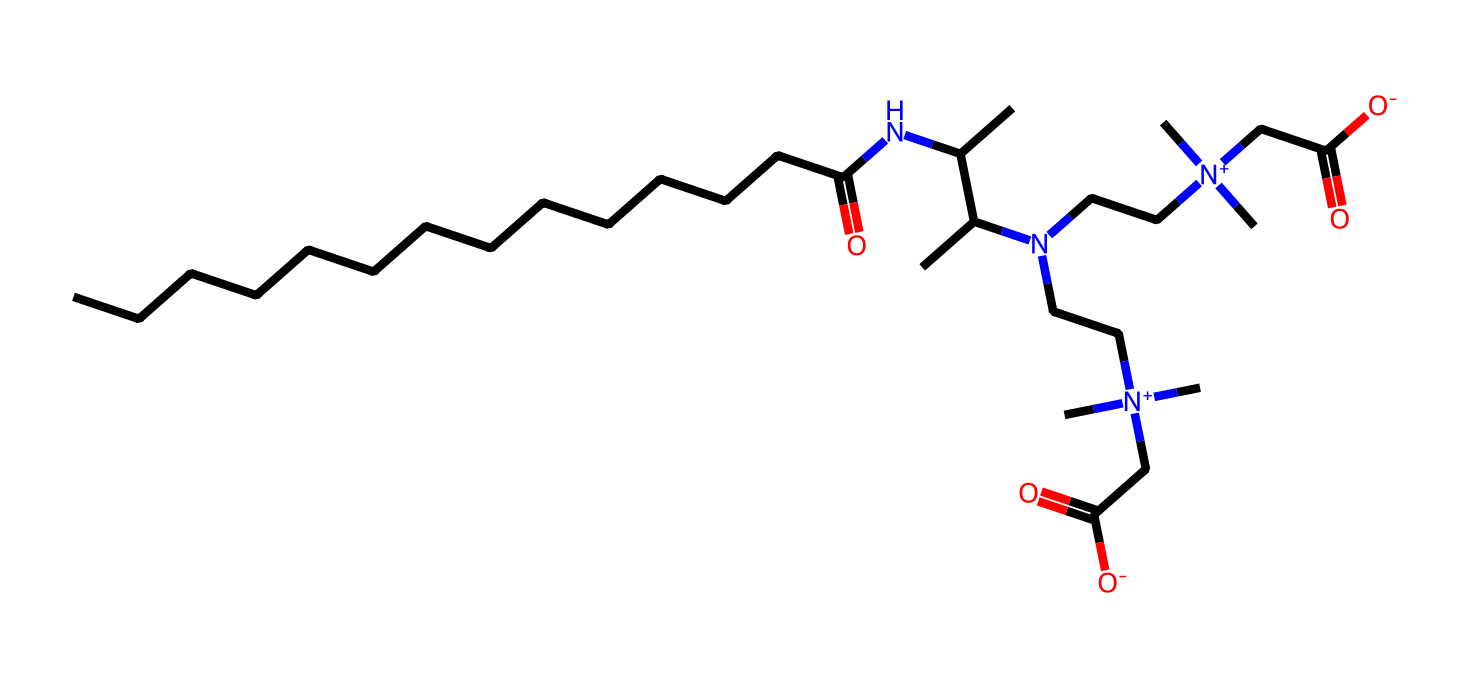What is the total number of carbon atoms in cocamidopropyl betaine? By examining the SMILES representation, count the carbon atoms (C) included in both the long carbon chain and within the functional groups. This results in 15 carbon atoms being identified.
Answer: 15 How many nitrogen atoms are present in the molecule? In the SMILES structure, count the occurrences of the nitrogen symbol (N). Two nitrogen atoms were found in the molecule structure.
Answer: 2 What functional group is associated with the amine in this surfactant? The structure shows the presence of a nitrogen atom connected to carbon chains, indicating it is an amine functional group. This is a primary feature of the surfactant's properties.
Answer: amine How many carboxylate groups does cocamidopropyl betaine have? By identifying the structures within the molecule, specifically looking for the groups that have the carboxylate (-COO-) structure, there are 2 carboxylate groups present in the SMILES representation.
Answer: 2 What is the overall charge of this surfactant molecule? The presence of positively charged nitrogen atoms ([N+]) combined with negatively charged carboxyl groups ([O-]) must be examined. The equal count of positive and negative charges results in a zwitterionic charge overall.
Answer: zwitterionic Which part of the molecule contributes to its surfactant properties? The hydrophobic long carbon chain interacts with the hydrophilic head, which has the amine and carboxylate functionalities. This dual nature allows it to act efficiently as a surfactant.
Answer: hydrophobic chain and hydrophilic head What type of surfactant is cocamidopropyl betaine classified as? Cocamidopropyl betaine contains both a hydrophobic tail and a hydrophilic head, leading to its classification as an amphoteric surfactant.
Answer: amphoteric 